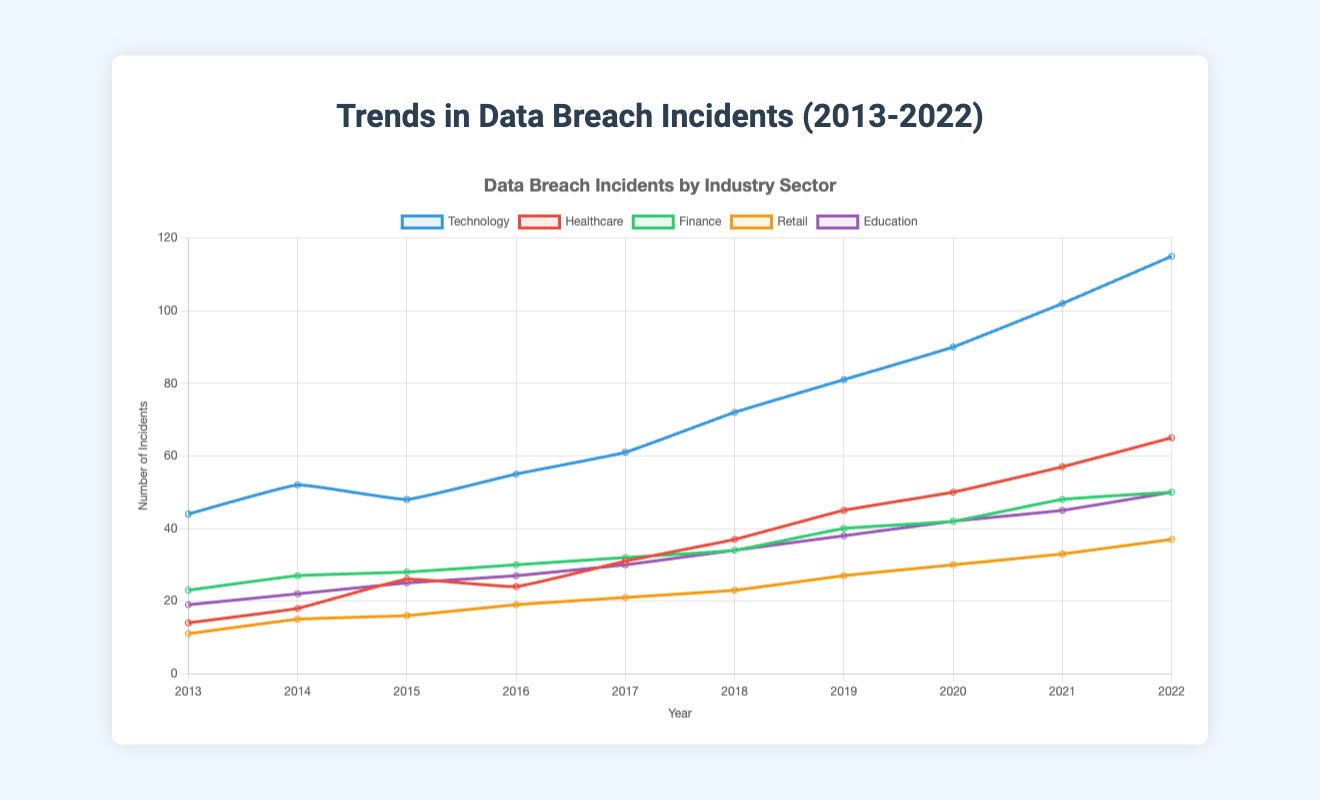Which industry had the highest number of data breach incidents in 2022? In 2022, the industry sectors are labeled with different colors, and the data points for the Technology sector are the highest among all different industry sectors.
Answer: Technology How many more data breach incidents were there in the Healthcare sector in 2022 compared to 2013? From the plot, we can see that the Healthcare sector had 65 incidents in 2022 and 14 in 2013. So, the difference is 65 - 14 = 51.
Answer: 51 Which sector showed the most gradual increase in data breach incidents over the decade? By analyzing the slopes of the lines, the Education sector shows a relatively steady but slower increase compared to others. The difference between the years is more evenly spread out.
Answer: Education How many data breach incidents were there in the Finance sector across the decade from 2013 to 2022? Sum the number of data breaches for the Finance sector from each year: 23 + 27 + 28 + 30 + 32 + 34 + 40 + 42 + 48 + 50 = 354.
Answer: 354 Compare the number of data breach incidents in the Technology and Retail sectors in 2018. Which sector had more incidents, and by how much? In 2018, the Technology sector had 72 incidents, and the Retail sector had 23. The difference is 72 - 23 = 49.
Answer: Technology, 49 What was the average number of data breach incidents in the Retail sector from 2013 to 2022? Sum the number of data breaches in the Retail sector for each year and divide by the number of years: (11 + 15 + 16 + 19 + 21 + 23 + 27 + 30 + 33 + 37) / 10 = 23.2.
Answer: 23.2 Which year did the Healthcare sector surpass 50 data breach incidents for the first time? Check the line for the Healthcare sector and observe that it surpasses 50 in 2020.
Answer: 2020 Between 2016 and 2022, which sector had the smallest increase in data breach incidents numbers? From 2016 to 2022, the Finance sector increased from 30 to 50, an increase of 20. The Retail sector increased from 19 to 37, an increase of 18. The Education sector increased from 27 to 50, an increase of 23. The Technology sector increased from 55 to 115, an increase of 60. The Healthcare sector increased from 24 to 65, an increase of 41. The Retail sector had the smallest increase.
Answer: Retail In which year did data breach incidents in the Technology sector reach a three-digit value? Observe the plot for the Technology sector and see that it surpasses 100 in 2021, reaching 102 incidents.
Answer: 2021 